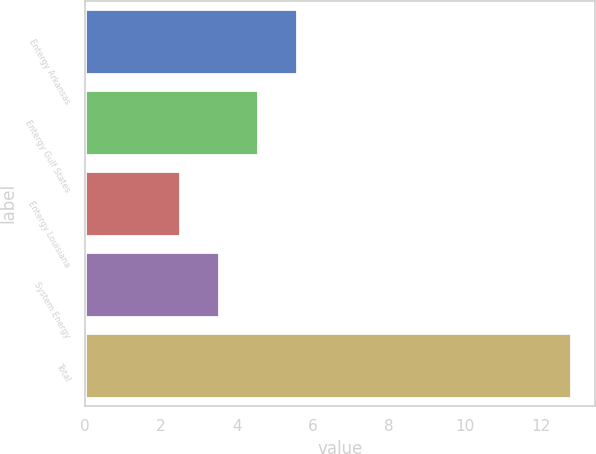Convert chart. <chart><loc_0><loc_0><loc_500><loc_500><bar_chart><fcel>Entergy Arkansas<fcel>Entergy Gulf States<fcel>Entergy Louisiana<fcel>System Energy<fcel>Total<nl><fcel>5.59<fcel>4.56<fcel>2.5<fcel>3.53<fcel>12.8<nl></chart> 